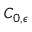Convert formula to latex. <formula><loc_0><loc_0><loc_500><loc_500>C _ { 0 , \epsilon }</formula> 